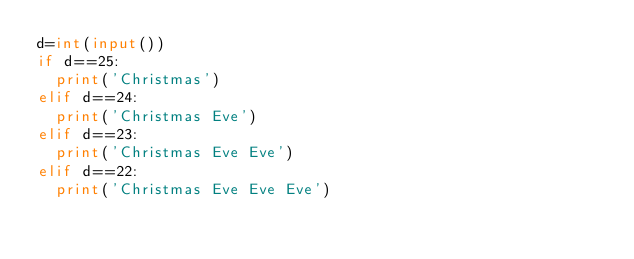<code> <loc_0><loc_0><loc_500><loc_500><_Python_>d=int(input())
if d==25:
  print('Christmas')
elif d==24:
  print('Christmas Eve')
elif d==23:
  print('Christmas Eve Eve')
elif d==22:
  print('Christmas Eve Eve Eve')</code> 